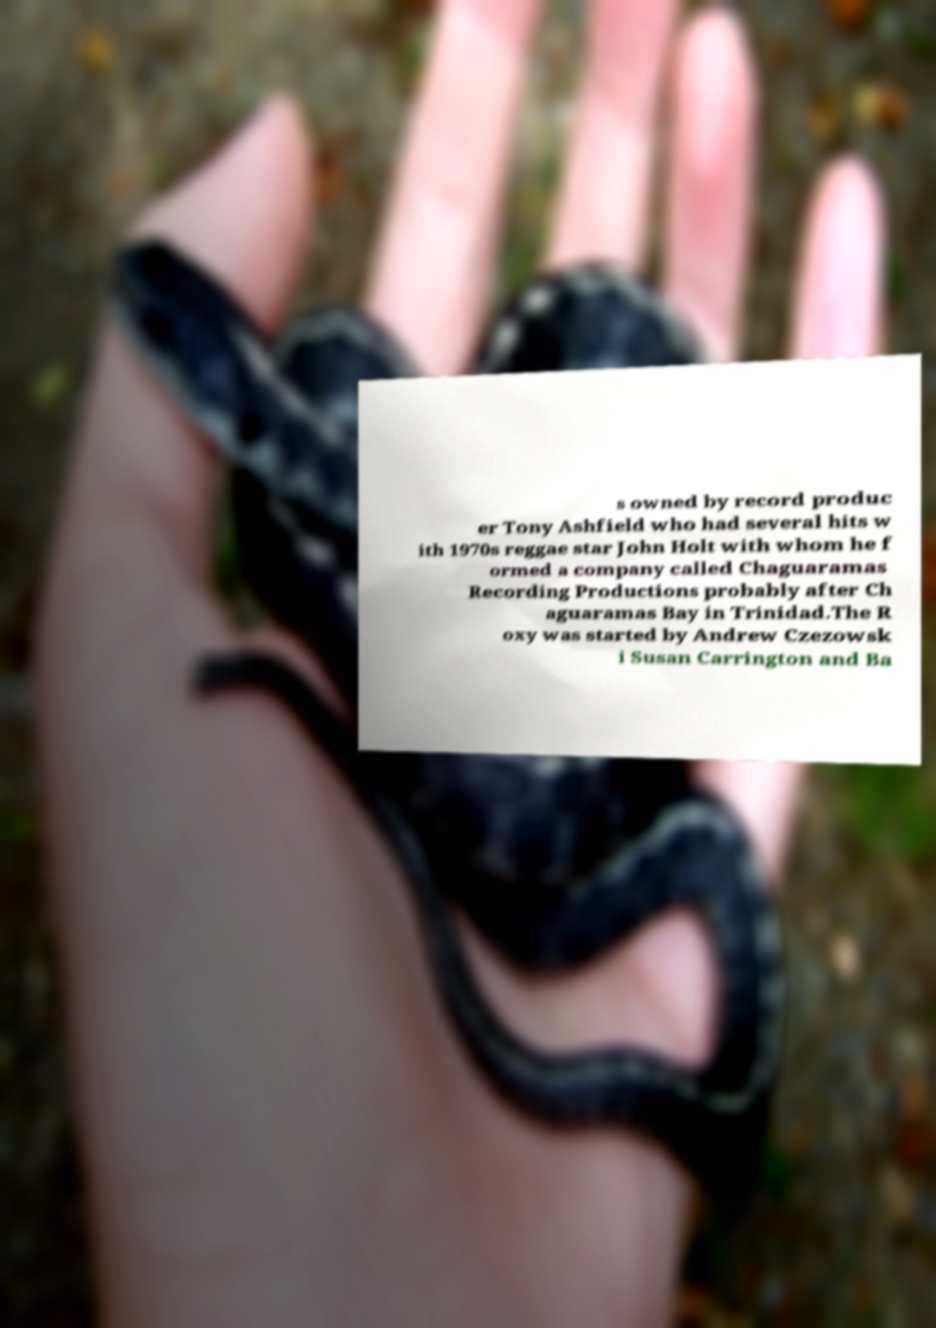Could you extract and type out the text from this image? s owned by record produc er Tony Ashfield who had several hits w ith 1970s reggae star John Holt with whom he f ormed a company called Chaguaramas Recording Productions probably after Ch aguaramas Bay in Trinidad.The R oxy was started by Andrew Czezowsk i Susan Carrington and Ba 